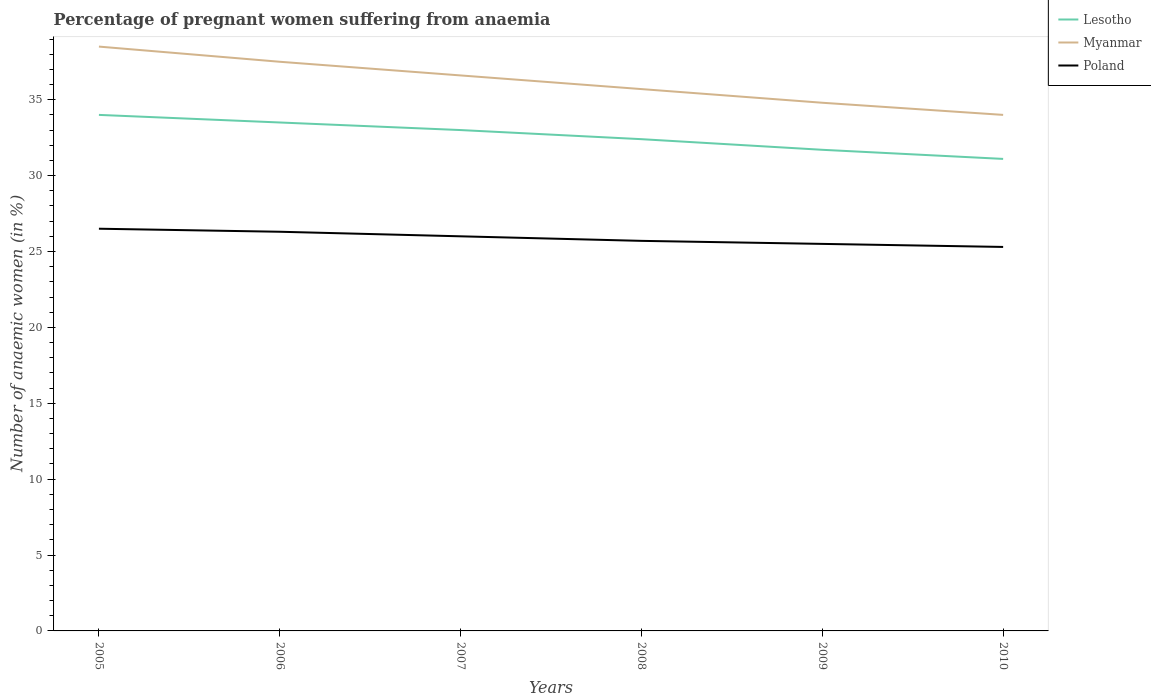How many different coloured lines are there?
Provide a short and direct response. 3. Does the line corresponding to Poland intersect with the line corresponding to Myanmar?
Your answer should be very brief. No. Across all years, what is the maximum number of anaemic women in Poland?
Your response must be concise. 25.3. In which year was the number of anaemic women in Poland maximum?
Give a very brief answer. 2010. What is the total number of anaemic women in Myanmar in the graph?
Your answer should be compact. 0.8. What is the difference between the highest and the second highest number of anaemic women in Poland?
Your response must be concise. 1.2. How many years are there in the graph?
Your answer should be compact. 6. Does the graph contain any zero values?
Ensure brevity in your answer.  No. Does the graph contain grids?
Ensure brevity in your answer.  No. How many legend labels are there?
Your answer should be very brief. 3. What is the title of the graph?
Provide a succinct answer. Percentage of pregnant women suffering from anaemia. What is the label or title of the X-axis?
Offer a terse response. Years. What is the label or title of the Y-axis?
Your answer should be compact. Number of anaemic women (in %). What is the Number of anaemic women (in %) in Myanmar in 2005?
Make the answer very short. 38.5. What is the Number of anaemic women (in %) in Poland in 2005?
Give a very brief answer. 26.5. What is the Number of anaemic women (in %) in Lesotho in 2006?
Provide a succinct answer. 33.5. What is the Number of anaemic women (in %) of Myanmar in 2006?
Provide a succinct answer. 37.5. What is the Number of anaemic women (in %) in Poland in 2006?
Ensure brevity in your answer.  26.3. What is the Number of anaemic women (in %) of Lesotho in 2007?
Keep it short and to the point. 33. What is the Number of anaemic women (in %) in Myanmar in 2007?
Give a very brief answer. 36.6. What is the Number of anaemic women (in %) in Lesotho in 2008?
Make the answer very short. 32.4. What is the Number of anaemic women (in %) of Myanmar in 2008?
Give a very brief answer. 35.7. What is the Number of anaemic women (in %) in Poland in 2008?
Provide a succinct answer. 25.7. What is the Number of anaemic women (in %) in Lesotho in 2009?
Keep it short and to the point. 31.7. What is the Number of anaemic women (in %) in Myanmar in 2009?
Offer a very short reply. 34.8. What is the Number of anaemic women (in %) of Poland in 2009?
Offer a very short reply. 25.5. What is the Number of anaemic women (in %) in Lesotho in 2010?
Make the answer very short. 31.1. What is the Number of anaemic women (in %) of Myanmar in 2010?
Provide a short and direct response. 34. What is the Number of anaemic women (in %) in Poland in 2010?
Ensure brevity in your answer.  25.3. Across all years, what is the maximum Number of anaemic women (in %) of Myanmar?
Your answer should be very brief. 38.5. Across all years, what is the minimum Number of anaemic women (in %) of Lesotho?
Offer a terse response. 31.1. Across all years, what is the minimum Number of anaemic women (in %) in Myanmar?
Ensure brevity in your answer.  34. Across all years, what is the minimum Number of anaemic women (in %) in Poland?
Offer a very short reply. 25.3. What is the total Number of anaemic women (in %) in Lesotho in the graph?
Provide a succinct answer. 195.7. What is the total Number of anaemic women (in %) of Myanmar in the graph?
Your answer should be very brief. 217.1. What is the total Number of anaemic women (in %) in Poland in the graph?
Ensure brevity in your answer.  155.3. What is the difference between the Number of anaemic women (in %) in Lesotho in 2005 and that in 2006?
Provide a succinct answer. 0.5. What is the difference between the Number of anaemic women (in %) of Myanmar in 2005 and that in 2006?
Make the answer very short. 1. What is the difference between the Number of anaemic women (in %) in Poland in 2005 and that in 2006?
Ensure brevity in your answer.  0.2. What is the difference between the Number of anaemic women (in %) in Myanmar in 2005 and that in 2007?
Keep it short and to the point. 1.9. What is the difference between the Number of anaemic women (in %) in Poland in 2005 and that in 2008?
Ensure brevity in your answer.  0.8. What is the difference between the Number of anaemic women (in %) of Lesotho in 2005 and that in 2009?
Make the answer very short. 2.3. What is the difference between the Number of anaemic women (in %) in Myanmar in 2005 and that in 2010?
Provide a short and direct response. 4.5. What is the difference between the Number of anaemic women (in %) in Poland in 2006 and that in 2007?
Give a very brief answer. 0.3. What is the difference between the Number of anaemic women (in %) in Myanmar in 2006 and that in 2008?
Provide a succinct answer. 1.8. What is the difference between the Number of anaemic women (in %) in Poland in 2006 and that in 2008?
Your response must be concise. 0.6. What is the difference between the Number of anaemic women (in %) in Poland in 2006 and that in 2009?
Your answer should be compact. 0.8. What is the difference between the Number of anaemic women (in %) of Lesotho in 2006 and that in 2010?
Provide a succinct answer. 2.4. What is the difference between the Number of anaemic women (in %) in Poland in 2006 and that in 2010?
Your response must be concise. 1. What is the difference between the Number of anaemic women (in %) of Myanmar in 2007 and that in 2008?
Give a very brief answer. 0.9. What is the difference between the Number of anaemic women (in %) in Poland in 2007 and that in 2008?
Your answer should be very brief. 0.3. What is the difference between the Number of anaemic women (in %) of Myanmar in 2007 and that in 2009?
Offer a very short reply. 1.8. What is the difference between the Number of anaemic women (in %) of Lesotho in 2007 and that in 2010?
Keep it short and to the point. 1.9. What is the difference between the Number of anaemic women (in %) in Myanmar in 2007 and that in 2010?
Provide a succinct answer. 2.6. What is the difference between the Number of anaemic women (in %) of Poland in 2007 and that in 2010?
Your response must be concise. 0.7. What is the difference between the Number of anaemic women (in %) in Myanmar in 2008 and that in 2009?
Keep it short and to the point. 0.9. What is the difference between the Number of anaemic women (in %) in Myanmar in 2009 and that in 2010?
Offer a very short reply. 0.8. What is the difference between the Number of anaemic women (in %) in Myanmar in 2005 and the Number of anaemic women (in %) in Poland in 2006?
Your answer should be compact. 12.2. What is the difference between the Number of anaemic women (in %) in Myanmar in 2005 and the Number of anaemic women (in %) in Poland in 2007?
Provide a short and direct response. 12.5. What is the difference between the Number of anaemic women (in %) of Myanmar in 2005 and the Number of anaemic women (in %) of Poland in 2008?
Make the answer very short. 12.8. What is the difference between the Number of anaemic women (in %) of Lesotho in 2005 and the Number of anaemic women (in %) of Myanmar in 2009?
Offer a very short reply. -0.8. What is the difference between the Number of anaemic women (in %) of Lesotho in 2005 and the Number of anaemic women (in %) of Poland in 2009?
Give a very brief answer. 8.5. What is the difference between the Number of anaemic women (in %) in Myanmar in 2005 and the Number of anaemic women (in %) in Poland in 2009?
Your answer should be very brief. 13. What is the difference between the Number of anaemic women (in %) in Lesotho in 2005 and the Number of anaemic women (in %) in Poland in 2010?
Keep it short and to the point. 8.7. What is the difference between the Number of anaemic women (in %) of Lesotho in 2006 and the Number of anaemic women (in %) of Poland in 2007?
Offer a terse response. 7.5. What is the difference between the Number of anaemic women (in %) of Lesotho in 2006 and the Number of anaemic women (in %) of Myanmar in 2008?
Ensure brevity in your answer.  -2.2. What is the difference between the Number of anaemic women (in %) in Myanmar in 2006 and the Number of anaemic women (in %) in Poland in 2008?
Ensure brevity in your answer.  11.8. What is the difference between the Number of anaemic women (in %) of Lesotho in 2006 and the Number of anaemic women (in %) of Myanmar in 2009?
Provide a succinct answer. -1.3. What is the difference between the Number of anaemic women (in %) of Lesotho in 2006 and the Number of anaemic women (in %) of Myanmar in 2010?
Ensure brevity in your answer.  -0.5. What is the difference between the Number of anaemic women (in %) in Lesotho in 2007 and the Number of anaemic women (in %) in Myanmar in 2008?
Your response must be concise. -2.7. What is the difference between the Number of anaemic women (in %) in Myanmar in 2007 and the Number of anaemic women (in %) in Poland in 2008?
Make the answer very short. 10.9. What is the difference between the Number of anaemic women (in %) in Lesotho in 2007 and the Number of anaemic women (in %) in Myanmar in 2009?
Provide a succinct answer. -1.8. What is the difference between the Number of anaemic women (in %) of Lesotho in 2007 and the Number of anaemic women (in %) of Poland in 2009?
Your answer should be very brief. 7.5. What is the difference between the Number of anaemic women (in %) of Lesotho in 2008 and the Number of anaemic women (in %) of Myanmar in 2009?
Your response must be concise. -2.4. What is the difference between the Number of anaemic women (in %) in Myanmar in 2008 and the Number of anaemic women (in %) in Poland in 2009?
Offer a terse response. 10.2. What is the difference between the Number of anaemic women (in %) of Lesotho in 2008 and the Number of anaemic women (in %) of Myanmar in 2010?
Keep it short and to the point. -1.6. What is the difference between the Number of anaemic women (in %) of Lesotho in 2008 and the Number of anaemic women (in %) of Poland in 2010?
Ensure brevity in your answer.  7.1. What is the difference between the Number of anaemic women (in %) of Myanmar in 2008 and the Number of anaemic women (in %) of Poland in 2010?
Keep it short and to the point. 10.4. What is the difference between the Number of anaemic women (in %) of Myanmar in 2009 and the Number of anaemic women (in %) of Poland in 2010?
Make the answer very short. 9.5. What is the average Number of anaemic women (in %) in Lesotho per year?
Provide a short and direct response. 32.62. What is the average Number of anaemic women (in %) in Myanmar per year?
Offer a very short reply. 36.18. What is the average Number of anaemic women (in %) of Poland per year?
Offer a very short reply. 25.88. In the year 2005, what is the difference between the Number of anaemic women (in %) of Lesotho and Number of anaemic women (in %) of Myanmar?
Make the answer very short. -4.5. In the year 2006, what is the difference between the Number of anaemic women (in %) of Lesotho and Number of anaemic women (in %) of Poland?
Provide a short and direct response. 7.2. In the year 2008, what is the difference between the Number of anaemic women (in %) of Myanmar and Number of anaemic women (in %) of Poland?
Keep it short and to the point. 10. In the year 2009, what is the difference between the Number of anaemic women (in %) in Lesotho and Number of anaemic women (in %) in Myanmar?
Provide a short and direct response. -3.1. In the year 2009, what is the difference between the Number of anaemic women (in %) in Myanmar and Number of anaemic women (in %) in Poland?
Provide a short and direct response. 9.3. In the year 2010, what is the difference between the Number of anaemic women (in %) of Lesotho and Number of anaemic women (in %) of Poland?
Provide a short and direct response. 5.8. In the year 2010, what is the difference between the Number of anaemic women (in %) of Myanmar and Number of anaemic women (in %) of Poland?
Ensure brevity in your answer.  8.7. What is the ratio of the Number of anaemic women (in %) of Lesotho in 2005 to that in 2006?
Make the answer very short. 1.01. What is the ratio of the Number of anaemic women (in %) in Myanmar in 2005 to that in 2006?
Make the answer very short. 1.03. What is the ratio of the Number of anaemic women (in %) in Poland in 2005 to that in 2006?
Offer a very short reply. 1.01. What is the ratio of the Number of anaemic women (in %) in Lesotho in 2005 to that in 2007?
Your answer should be very brief. 1.03. What is the ratio of the Number of anaemic women (in %) in Myanmar in 2005 to that in 2007?
Provide a succinct answer. 1.05. What is the ratio of the Number of anaemic women (in %) of Poland in 2005 to that in 2007?
Your response must be concise. 1.02. What is the ratio of the Number of anaemic women (in %) of Lesotho in 2005 to that in 2008?
Make the answer very short. 1.05. What is the ratio of the Number of anaemic women (in %) in Myanmar in 2005 to that in 2008?
Offer a terse response. 1.08. What is the ratio of the Number of anaemic women (in %) of Poland in 2005 to that in 2008?
Your answer should be compact. 1.03. What is the ratio of the Number of anaemic women (in %) of Lesotho in 2005 to that in 2009?
Provide a succinct answer. 1.07. What is the ratio of the Number of anaemic women (in %) of Myanmar in 2005 to that in 2009?
Your response must be concise. 1.11. What is the ratio of the Number of anaemic women (in %) in Poland in 2005 to that in 2009?
Offer a terse response. 1.04. What is the ratio of the Number of anaemic women (in %) in Lesotho in 2005 to that in 2010?
Make the answer very short. 1.09. What is the ratio of the Number of anaemic women (in %) of Myanmar in 2005 to that in 2010?
Offer a terse response. 1.13. What is the ratio of the Number of anaemic women (in %) in Poland in 2005 to that in 2010?
Your answer should be compact. 1.05. What is the ratio of the Number of anaemic women (in %) of Lesotho in 2006 to that in 2007?
Offer a very short reply. 1.02. What is the ratio of the Number of anaemic women (in %) of Myanmar in 2006 to that in 2007?
Give a very brief answer. 1.02. What is the ratio of the Number of anaemic women (in %) in Poland in 2006 to that in 2007?
Provide a short and direct response. 1.01. What is the ratio of the Number of anaemic women (in %) in Lesotho in 2006 to that in 2008?
Give a very brief answer. 1.03. What is the ratio of the Number of anaemic women (in %) of Myanmar in 2006 to that in 2008?
Ensure brevity in your answer.  1.05. What is the ratio of the Number of anaemic women (in %) in Poland in 2006 to that in 2008?
Ensure brevity in your answer.  1.02. What is the ratio of the Number of anaemic women (in %) in Lesotho in 2006 to that in 2009?
Your answer should be compact. 1.06. What is the ratio of the Number of anaemic women (in %) in Myanmar in 2006 to that in 2009?
Ensure brevity in your answer.  1.08. What is the ratio of the Number of anaemic women (in %) in Poland in 2006 to that in 2009?
Provide a succinct answer. 1.03. What is the ratio of the Number of anaemic women (in %) in Lesotho in 2006 to that in 2010?
Offer a terse response. 1.08. What is the ratio of the Number of anaemic women (in %) in Myanmar in 2006 to that in 2010?
Your response must be concise. 1.1. What is the ratio of the Number of anaemic women (in %) of Poland in 2006 to that in 2010?
Keep it short and to the point. 1.04. What is the ratio of the Number of anaemic women (in %) of Lesotho in 2007 to that in 2008?
Give a very brief answer. 1.02. What is the ratio of the Number of anaemic women (in %) of Myanmar in 2007 to that in 2008?
Your answer should be very brief. 1.03. What is the ratio of the Number of anaemic women (in %) in Poland in 2007 to that in 2008?
Keep it short and to the point. 1.01. What is the ratio of the Number of anaemic women (in %) in Lesotho in 2007 to that in 2009?
Keep it short and to the point. 1.04. What is the ratio of the Number of anaemic women (in %) in Myanmar in 2007 to that in 2009?
Ensure brevity in your answer.  1.05. What is the ratio of the Number of anaemic women (in %) in Poland in 2007 to that in 2009?
Offer a very short reply. 1.02. What is the ratio of the Number of anaemic women (in %) of Lesotho in 2007 to that in 2010?
Make the answer very short. 1.06. What is the ratio of the Number of anaemic women (in %) of Myanmar in 2007 to that in 2010?
Your answer should be compact. 1.08. What is the ratio of the Number of anaemic women (in %) in Poland in 2007 to that in 2010?
Make the answer very short. 1.03. What is the ratio of the Number of anaemic women (in %) of Lesotho in 2008 to that in 2009?
Keep it short and to the point. 1.02. What is the ratio of the Number of anaemic women (in %) in Myanmar in 2008 to that in 2009?
Provide a short and direct response. 1.03. What is the ratio of the Number of anaemic women (in %) in Poland in 2008 to that in 2009?
Offer a terse response. 1.01. What is the ratio of the Number of anaemic women (in %) of Lesotho in 2008 to that in 2010?
Provide a succinct answer. 1.04. What is the ratio of the Number of anaemic women (in %) in Poland in 2008 to that in 2010?
Make the answer very short. 1.02. What is the ratio of the Number of anaemic women (in %) in Lesotho in 2009 to that in 2010?
Your response must be concise. 1.02. What is the ratio of the Number of anaemic women (in %) of Myanmar in 2009 to that in 2010?
Your response must be concise. 1.02. What is the ratio of the Number of anaemic women (in %) in Poland in 2009 to that in 2010?
Offer a very short reply. 1.01. What is the difference between the highest and the second highest Number of anaemic women (in %) of Myanmar?
Make the answer very short. 1. What is the difference between the highest and the lowest Number of anaemic women (in %) in Myanmar?
Your response must be concise. 4.5. 